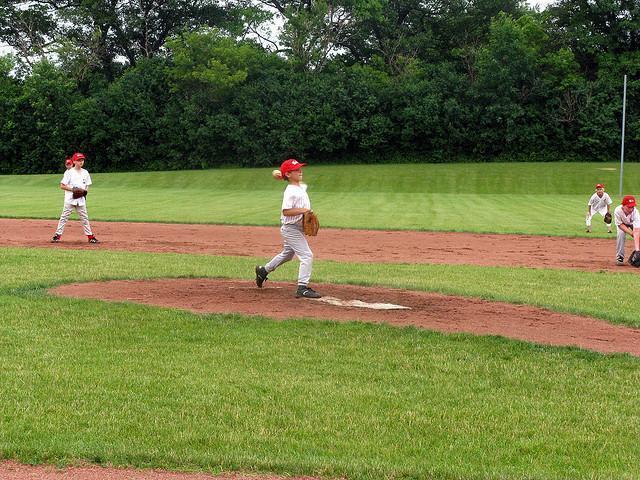How many open umbrellas are in the scene?
Give a very brief answer. 0. 